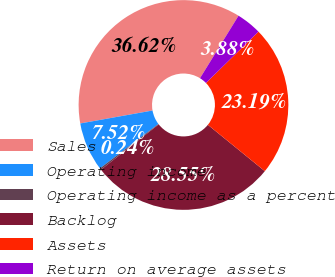<chart> <loc_0><loc_0><loc_500><loc_500><pie_chart><fcel>Sales<fcel>Operating income<fcel>Operating income as a percent<fcel>Backlog<fcel>Assets<fcel>Return on average assets<nl><fcel>36.62%<fcel>7.52%<fcel>0.24%<fcel>28.55%<fcel>23.19%<fcel>3.88%<nl></chart> 